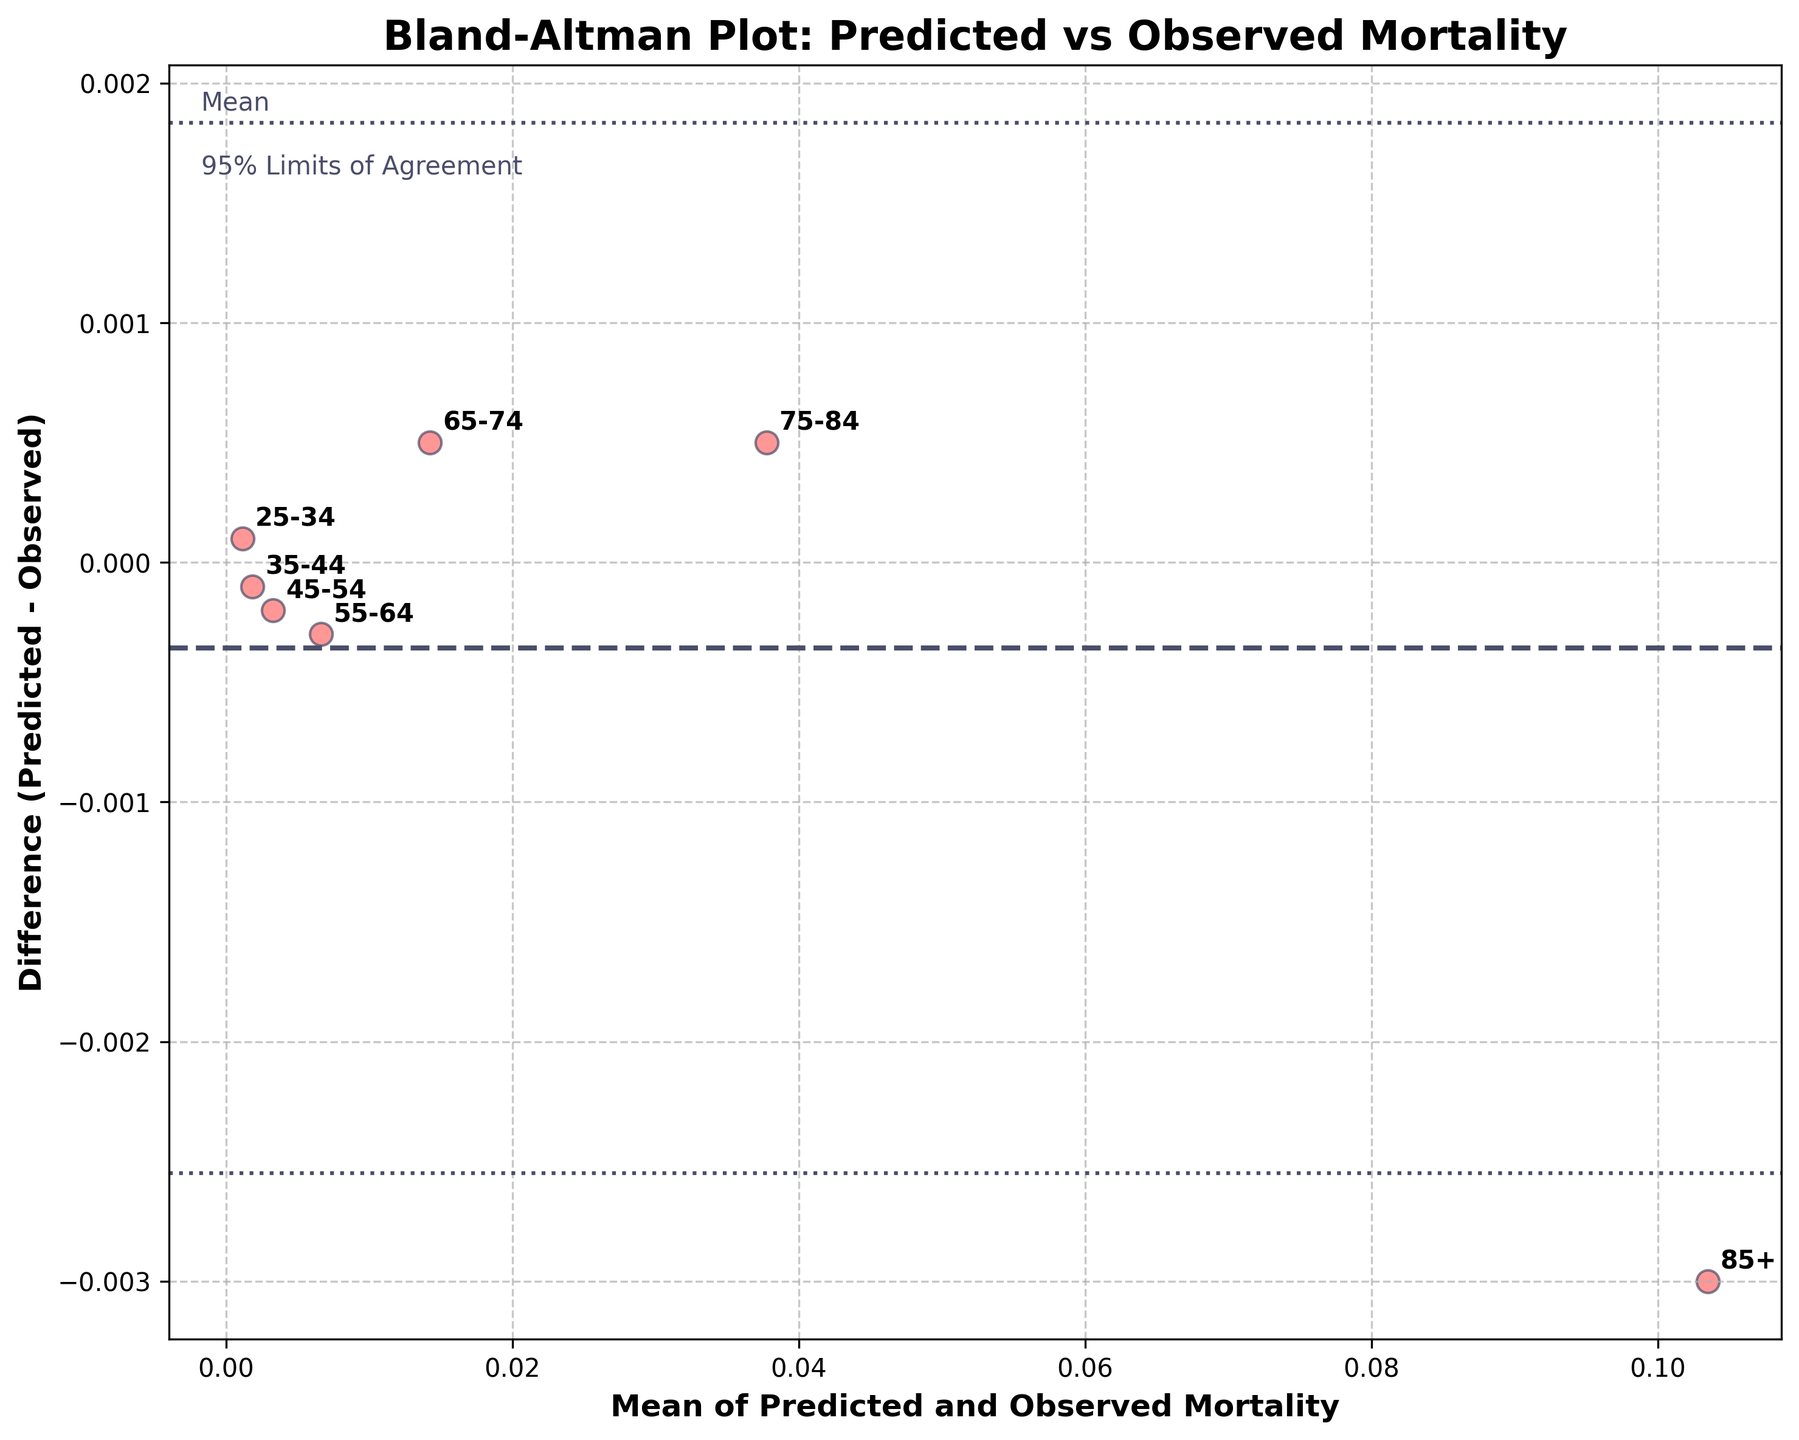what is the title of the figure? The title of the figure is placed at the top and generally describes what the graph is about. By looking at the graphical plot, we can see the title.
Answer: Bland-Altman Plot: Predicted vs Observed Mortality How many data points are represented in the plot? Each data point corresponds to an age group, and we should count the number of unique age-group labels.
Answer: 7 What are the x-axis and y-axis labels? The x-axis and y-axis are labelled to describe what each axis represents, usually found near the axis.
Answer: x-axis: Mean of Predicted and Observed Mortality, y-axis: Difference (Predicted - Observed) Which age group has the largest positive difference? Look for the data point that has the highest position above the x-axis among the labeled groups.
Answer: 75-84 and 65-74 What does the dashed line represent? The dashed line is usually annotated or described in the plot legend or text. This line often represents an average or mean value.
Answer: Mean difference What is the maximum positive difference? This question requires locating the highest data point above the y-axis (where y > 0) and noting its y-value.
Answer: 0.0005 What is the age group with the largest absolute difference? Compare the values of the differences for all age groups, and identify the highest value considering both positive and negative signs.
Answer: 85+ Which age group’s difference is closest to zero? Identify the data point that lies closest to the horizontal line at y = 0, which represents the smallest magnitude difference.
Answer: 35-44 What are the 95% limits of agreement? To locate the 95% limits of agreement, find the lines that are usually parallel to the mean line, typically annotated, and can be calculated as mean difference ± 1.96*std difference.
Answer: Mean difference ± 1.96*std deviation How do the differences evolve as the mean mortality rate increases? Observe the trend of the data points spread across the x-axis: we need to note if the differences increase, decrease, or remain random with increasing x-values.
Answer: Differences do not show a clear trend; they remain relatively spread without a discernible pattern 